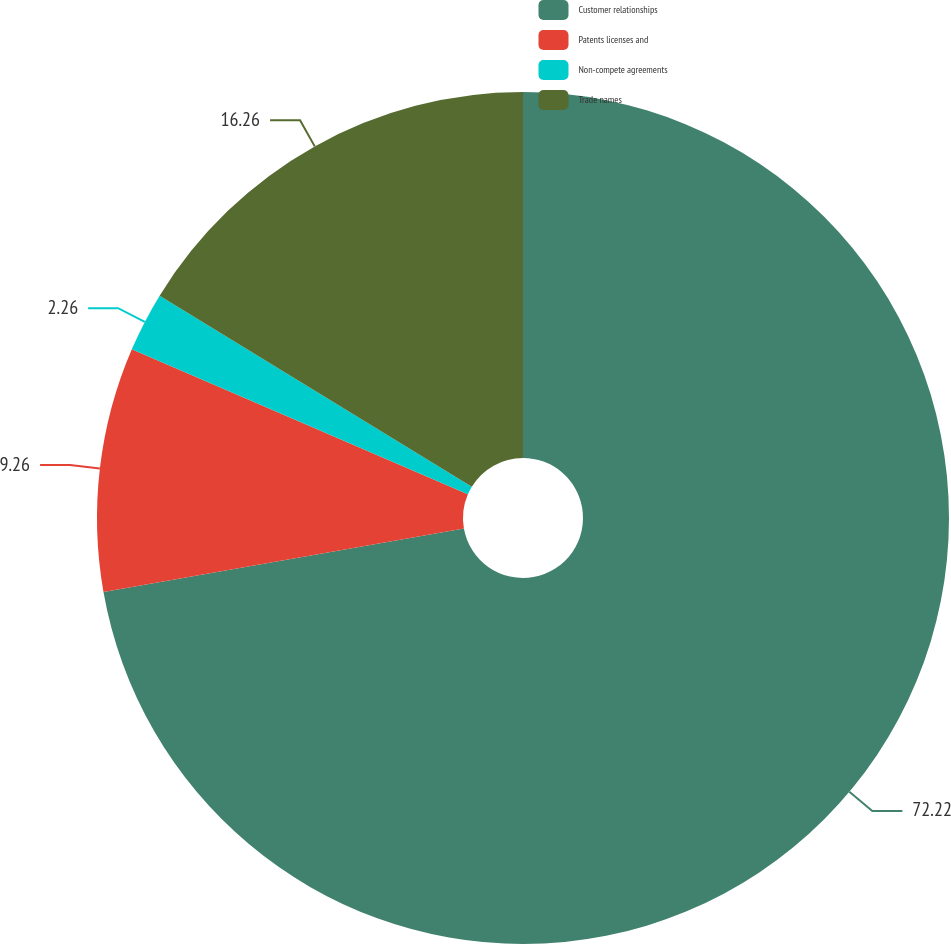<chart> <loc_0><loc_0><loc_500><loc_500><pie_chart><fcel>Customer relationships<fcel>Patents licenses and<fcel>Non-compete agreements<fcel>Trade names<nl><fcel>72.22%<fcel>9.26%<fcel>2.26%<fcel>16.26%<nl></chart> 